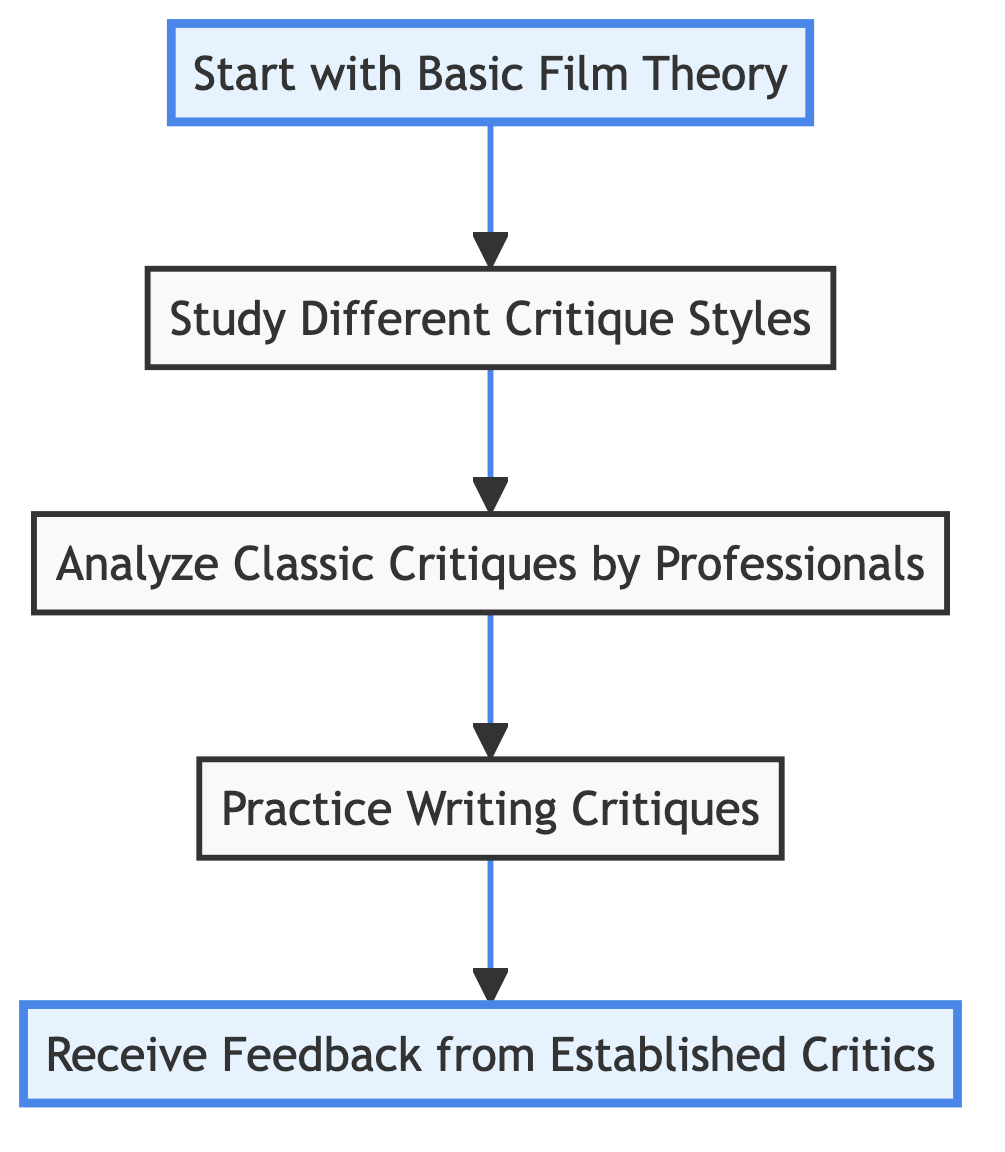What is the first step in the flow chart? The first step in the flow chart is represented at the bottom node and is labeled "Start with Basic Film Theory."
Answer: Start with Basic Film Theory How many steps are there in the flow chart? By counting the nodes in the flow chart, there are a total of five steps outlined in the process.
Answer: 5 What is the last step in the flow chart? The last step is at the top node and is labeled "Receive Feedback from Established Critics."
Answer: Receive Feedback from Established Critics Which step comes directly after analyzing classic critiques? Following "Analyze Classic Critiques by Professionals," the next step in the flow chart is "Practice Writing Critiques."
Answer: Practice Writing Critiques What type of critique styles are studied after basic film theory? After "Start with Basic Film Theory," the next step is "Study Different Critique Styles."
Answer: Study Different Critique Styles Which two steps are highlighted in the diagram? The highlighted steps at the bottom and top of the diagram are "Start with Basic Film Theory" and "Receive Feedback from Established Critics."
Answer: Start with Basic Film Theory, Receive Feedback from Established Critics How is "Practice Writing Critiques" positioned in relation to "Analyze Classic Critiques by Professionals"? "Practice Writing Critiques" is directly above "Analyze Classic Critiques by Professionals" in the flow of the chart.
Answer: Directly above What does the flow of the diagram indicate about the steps? The arrow pointing up in the flow chart indicates that the steps are meant to be taken in a sequential order from the bottom to the top.
Answer: Sequential order What type of diagram is this? This is a Bottom to Top Flow Chart, indicated by the direction of the arrows that point upward through the steps.
Answer: Bottom to Top Flow Chart 